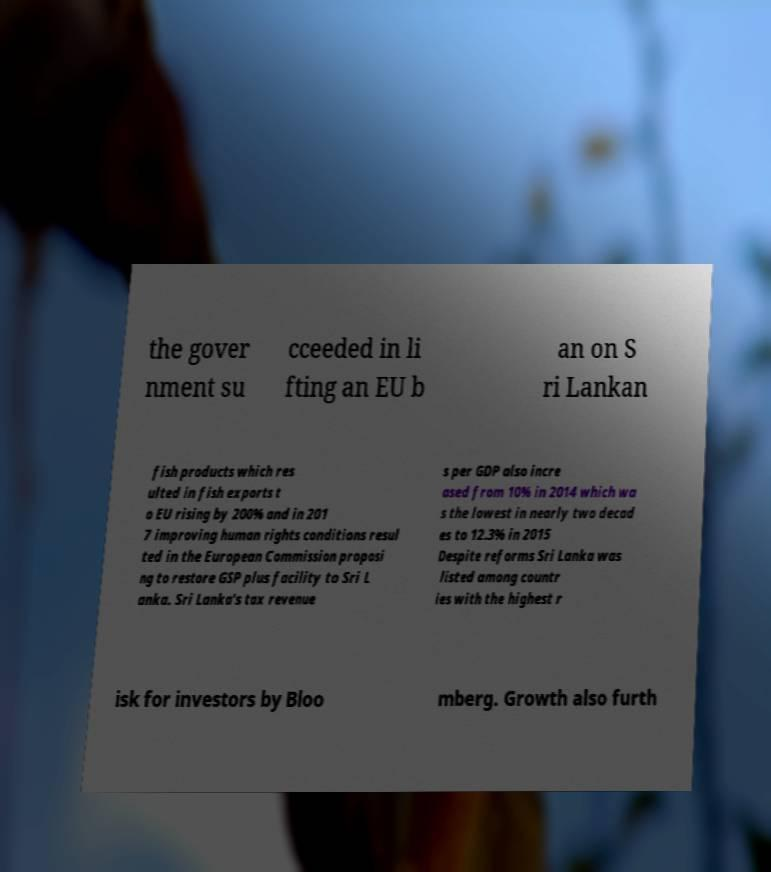Can you read and provide the text displayed in the image?This photo seems to have some interesting text. Can you extract and type it out for me? the gover nment su cceeded in li fting an EU b an on S ri Lankan fish products which res ulted in fish exports t o EU rising by 200% and in 201 7 improving human rights conditions resul ted in the European Commission proposi ng to restore GSP plus facility to Sri L anka. Sri Lanka's tax revenue s per GDP also incre ased from 10% in 2014 which wa s the lowest in nearly two decad es to 12.3% in 2015 Despite reforms Sri Lanka was listed among countr ies with the highest r isk for investors by Bloo mberg. Growth also furth 